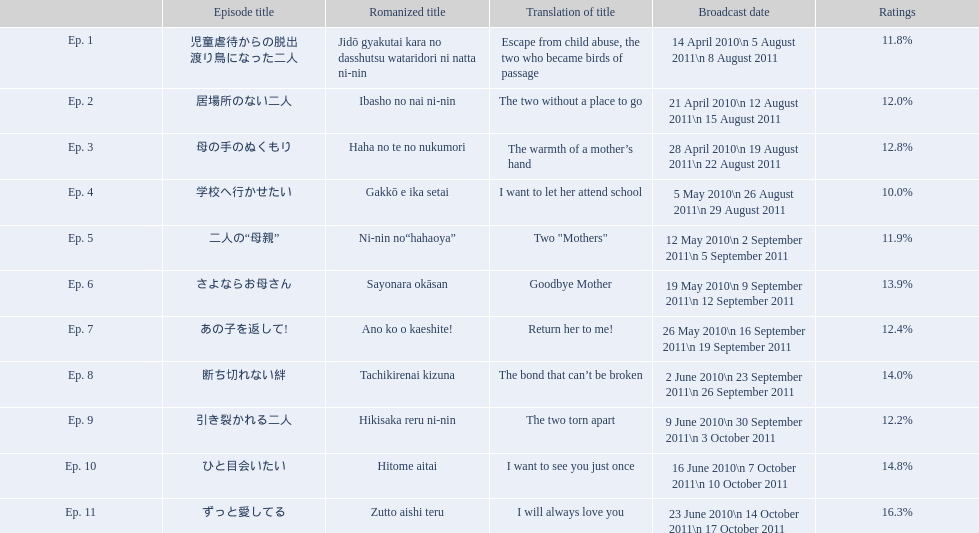What are the episodes of mother? 児童虐待からの脱出 渡り鳥になった二人, 居場所のない二人, 母の手のぬくもり, 学校へ行かせたい, 二人の“母親”, さよならお母さん, あの子を返して!, 断ち切れない絆, 引き裂かれる二人, ひと目会いたい, ずっと愛してる. What is the rating of episode 10? 14.8%. What is the other rating also in the 14 to 15 range? Ep. 8. 